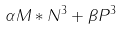<formula> <loc_0><loc_0><loc_500><loc_500>\alpha M * N ^ { 3 } + \beta P ^ { 3 }</formula> 